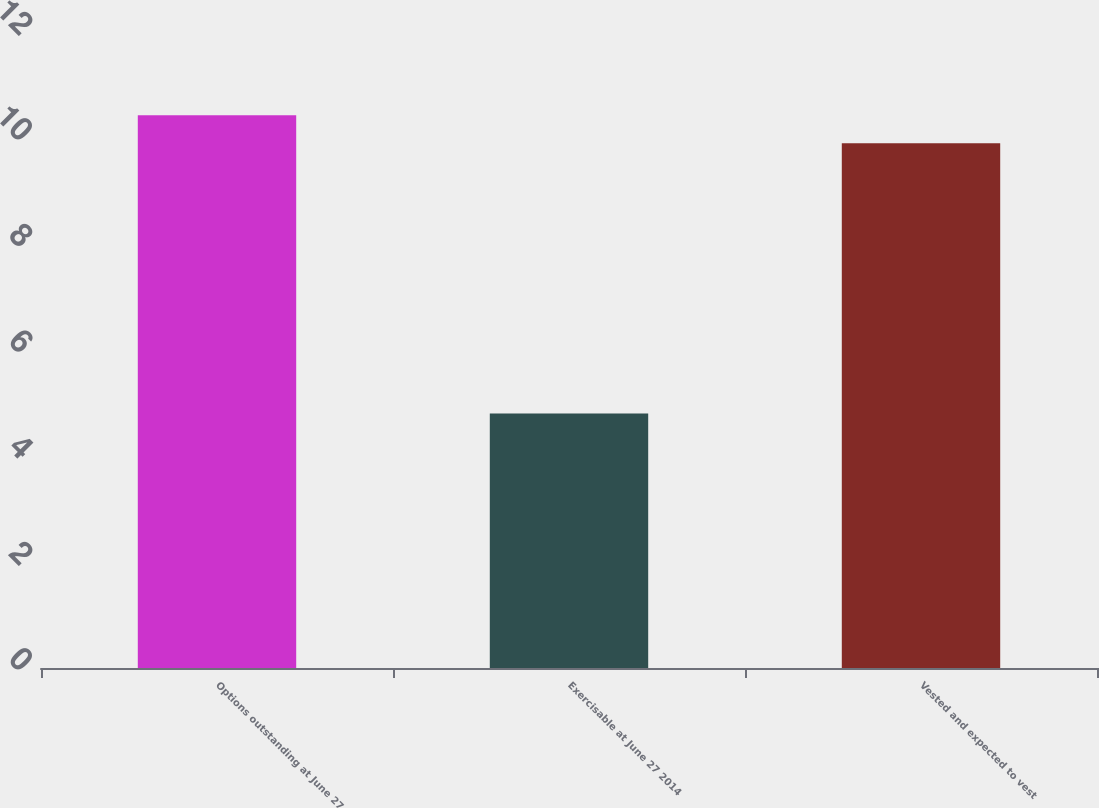<chart> <loc_0><loc_0><loc_500><loc_500><bar_chart><fcel>Options outstanding at June 27<fcel>Exercisable at June 27 2014<fcel>Vested and expected to vest<nl><fcel>10.43<fcel>4.8<fcel>9.9<nl></chart> 